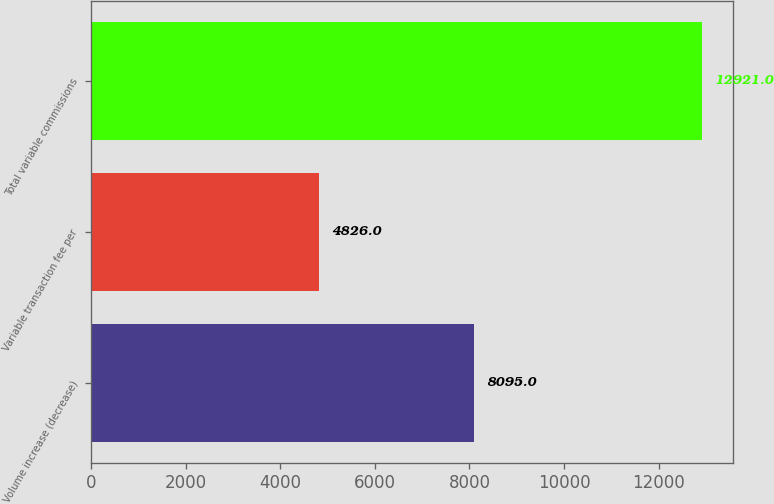<chart> <loc_0><loc_0><loc_500><loc_500><bar_chart><fcel>Volume increase (decrease)<fcel>Variable transaction fee per<fcel>Total variable commissions<nl><fcel>8095<fcel>4826<fcel>12921<nl></chart> 